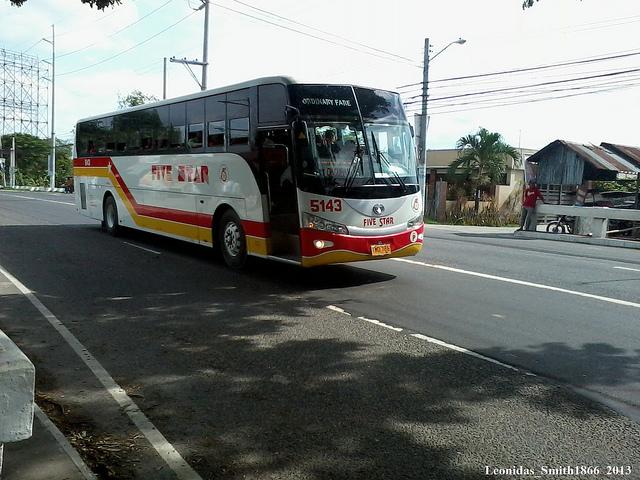Is the bus moving?
Short answer required. Yes. What number of bus is this?
Keep it brief. 5143. How many people are on the bus?
Write a very short answer. 20. 